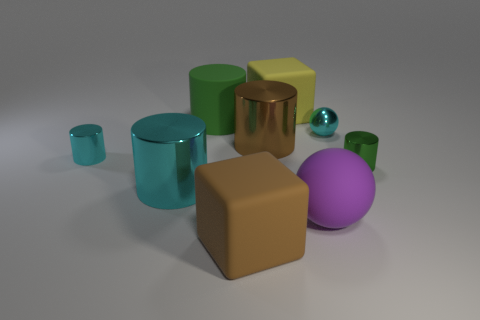Subtract all large brown cylinders. How many cylinders are left? 4 Subtract all brown cylinders. How many cylinders are left? 4 Subtract all blue cylinders. Subtract all green balls. How many cylinders are left? 5 Add 1 large matte cylinders. How many objects exist? 10 Subtract all cylinders. How many objects are left? 4 Subtract 0 blue blocks. How many objects are left? 9 Subtract all yellow blocks. Subtract all tiny green cylinders. How many objects are left? 7 Add 4 cyan spheres. How many cyan spheres are left? 5 Add 2 large metal cylinders. How many large metal cylinders exist? 4 